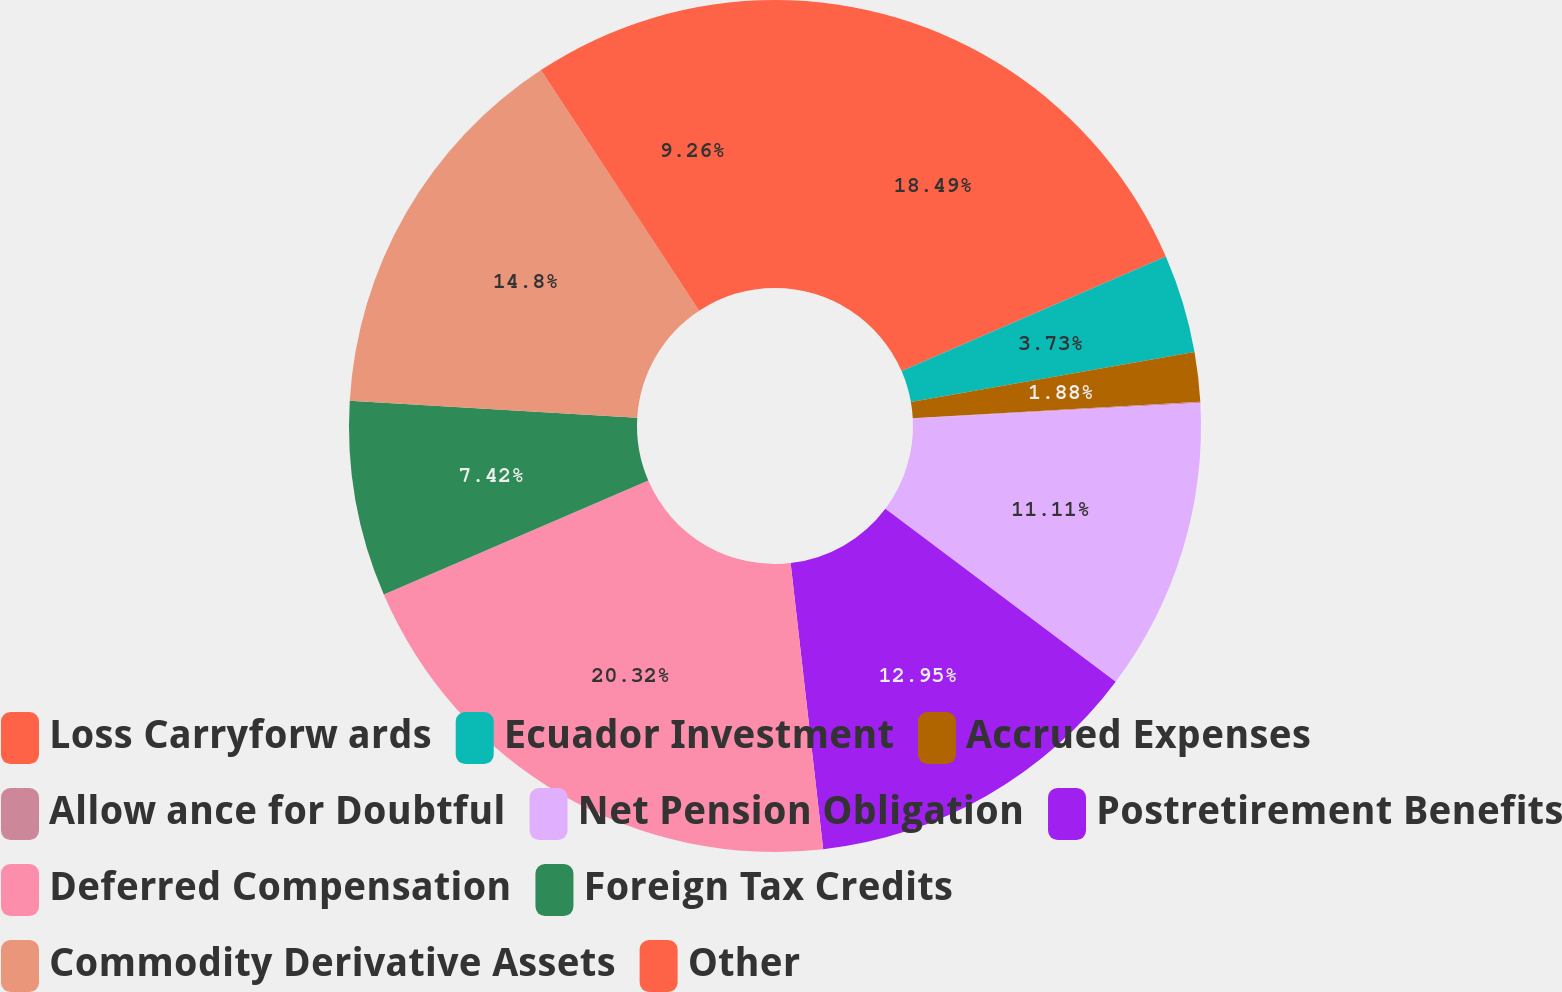Convert chart to OTSL. <chart><loc_0><loc_0><loc_500><loc_500><pie_chart><fcel>Loss Carryforw ards<fcel>Ecuador Investment<fcel>Accrued Expenses<fcel>Allow ance for Doubtful<fcel>Net Pension Obligation<fcel>Postretirement Benefits<fcel>Deferred Compensation<fcel>Foreign Tax Credits<fcel>Commodity Derivative Assets<fcel>Other<nl><fcel>18.49%<fcel>3.73%<fcel>1.88%<fcel>0.04%<fcel>11.11%<fcel>12.95%<fcel>20.33%<fcel>7.42%<fcel>14.8%<fcel>9.26%<nl></chart> 